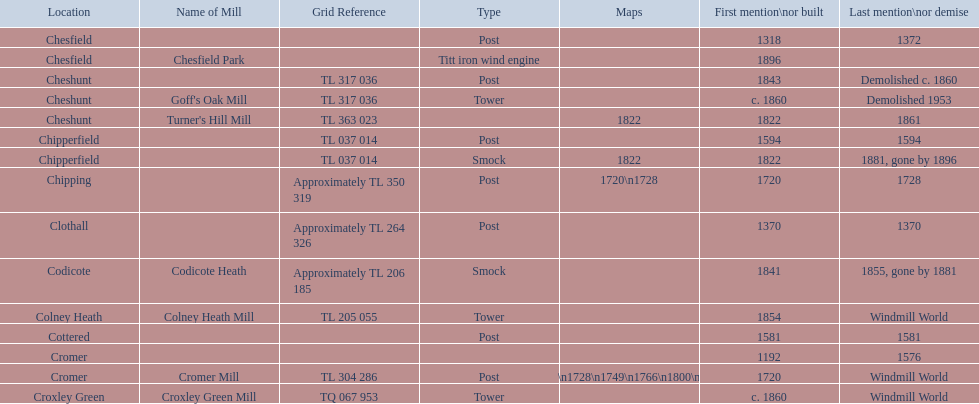What is the name of the only "c" mill located in colney health? Colney Heath Mill. 